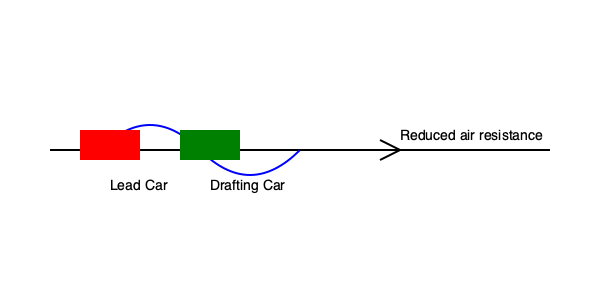In NASCAR racing, drafting is a crucial technique that can significantly impact lap times. Consider two cars on a straightaway, where the trailing car is drafting closely behind the lead car. If the drag coefficient of the trailing car is reduced by 25% due to drafting, and both cars are traveling at 200 mph (88.89 m/s) with an initial drag force of 4000 N, calculate the instantaneous power saved by the drafting car compared to its power consumption without drafting. To solve this problem, we'll follow these steps:

1) First, recall the formula for power related to drag force:
   $$ P = F_d \cdot v $$
   where $P$ is power, $F_d$ is drag force, and $v$ is velocity.

2) Calculate the initial power consumption without drafting:
   $$ P_1 = 4000 \text{ N} \cdot 88.89 \text{ m/s} = 355,560 \text{ W} $$

3) With drafting, the drag coefficient is reduced by 25%. Since drag force is directly proportional to the drag coefficient, the new drag force will be:
   $$ F_{d2} = 4000 \text{ N} \cdot (1 - 0.25) = 3000 \text{ N} $$

4) Calculate the new power consumption with drafting:
   $$ P_2 = 3000 \text{ N} \cdot 88.89 \text{ m/s} = 266,670 \text{ W} $$

5) Calculate the power saved:
   $$ P_{saved} = P_1 - P_2 = 355,560 \text{ W} - 266,670 \text{ W} = 88,890 \text{ W} $$

6) Convert to kilowatts:
   $$ P_{saved} = 88,890 \text{ W} = 88.89 \text{ kW} $$

Therefore, the instantaneous power saved by the drafting car is 88.89 kW.
Answer: 88.89 kW 